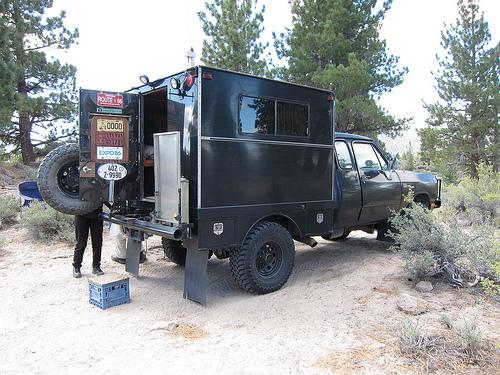Narrate the scene of the image in a poetic manner. Amidst the whispers of trees, a solitary truck, doors flung wide, awaits its purpose in the embrace of the wild. Tell a short story that can be inferred from the image. In a quiet, forested area, Max was delivering supplies when his truck suddenly broke down. Forced to unload the cargo, he opened the doors, revealing a spare tire and a blue crate, as he began assessing the situation. Explain the position of the main subject and two important objects around it. The black truck is positioned at the center, with a bush beside it to the right, and a blue crate slightly behind it, beside the open door. Describe the atmosphere and setting of the image. The image captures a serene outdoor scene in a forested area, with a black truck parked on a road, surrounded by lush greenery. Mention some important objects that can be found in the image and their positions. A black truck with an open door, a blue crate beside the door, a bush near the truck, and a person's legs under the spare tire. Write a brief information about the window of the truck. A large window appears on the side of the box truck with a clear view of the rear section of the vehicle. List three objects and their respective colors in the image. Truck: black, crate: blue, and bush: green. Provide a concise description of the main focus of the image. A black truck with its back door open and a spare tire attached on it is parked in the woods. Describe the image in the style of an advertisement for the truck. Experience the great outdoors with our rugged black truck, featuring a spacious rear with an easy-access door, a spare tire, and room for all your cargo. Adventure and nature beckon! Express the main elements of the image as a haiku (a three-line poem with a 5-7-5 syllable pattern). Nature whispers still. 